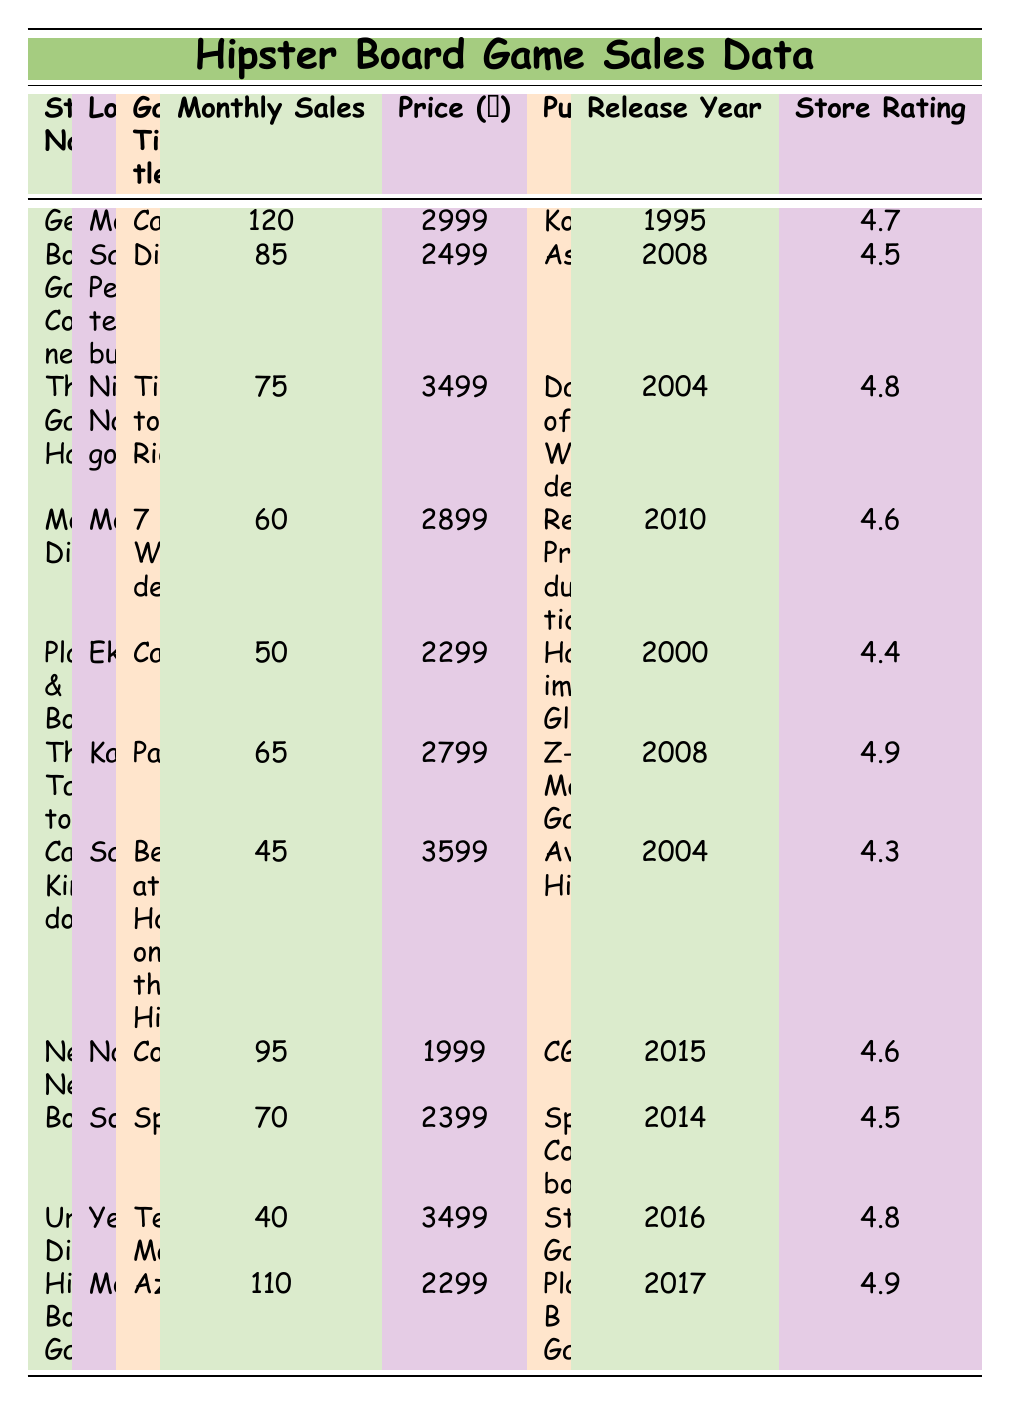What is the title of the game with the highest monthly sales? The table shows that "Catan" has the highest monthly sales at 120 units in "GeekTown" store.
Answer: Catan Which store has the lowest monthly sales, and what is the amount? "Urban Dice" in Yekaterinburg has the lowest monthly sales with 40 units.
Answer: Urban Dice, 40 What is the average price of the games listed in the table? The prices are: 2999, 2499, 3499, 2899, 2299, 2799, 3599, 1999, 2399, 3499, 2299. Adding these prices gives 30988 and dividing by 11 gives an average of 2817.09.
Answer: 2817.09 Is "Azul" rated higher than "Ticket to Ride"? "Azul" has a rating of 4.9 and "Ticket to Ride" has a rating of 4.8, so yes, Azul is rated higher.
Answer: Yes How many games have a store rating of 4.6 or higher? The games with ratings of 4.6 or higher are: "Catan", "7 Wonders", "The Tabletop", "Nerdy Nest", "Hipster Board Games". There are 5 such games.
Answer: 5 What is the total monthly sales for all games in Moscow? The total monthly sales for games in Moscow ("Catan" with 120, "7 Wonders" with 60, and "Azul" with 110) is 120 + 60 + 110 = 290.
Answer: 290 Which publisher has the game that has been released most recently? The most recently released game is "Terraforming Mars" from publisher "Stronghold Games" with a release year of 2016.
Answer: Stronghold Games Which location has the highest store rating among the entries? "The Tabletop" store in Kazan has the highest rating of 4.9.
Answer: Kazan What is the difference in monthly sales between "Codenames" and "Pandemic"? "Codenames" has 95 monthly sales and "Pandemic" has 65, thus the difference is 95 - 65 = 30.
Answer: 30 Are there any board games published by "Days of Wonder"? Yes, "Ticket to Ride" is published by "Days of Wonder".
Answer: Yes 